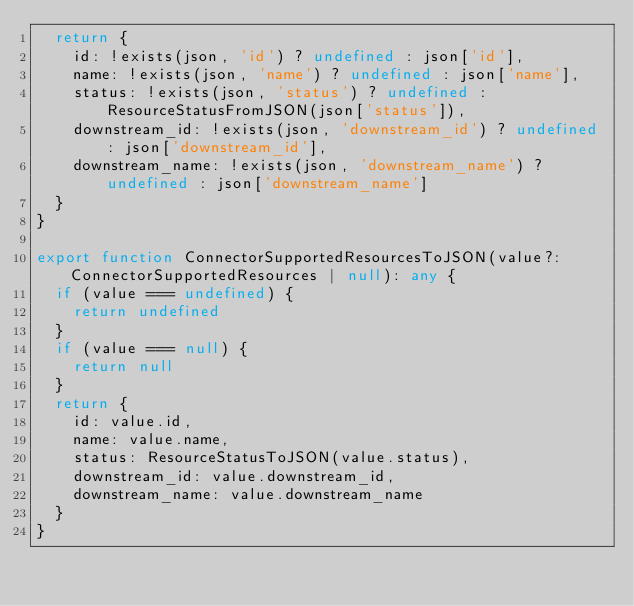Convert code to text. <code><loc_0><loc_0><loc_500><loc_500><_TypeScript_>  return {
    id: !exists(json, 'id') ? undefined : json['id'],
    name: !exists(json, 'name') ? undefined : json['name'],
    status: !exists(json, 'status') ? undefined : ResourceStatusFromJSON(json['status']),
    downstream_id: !exists(json, 'downstream_id') ? undefined : json['downstream_id'],
    downstream_name: !exists(json, 'downstream_name') ? undefined : json['downstream_name']
  }
}

export function ConnectorSupportedResourcesToJSON(value?: ConnectorSupportedResources | null): any {
  if (value === undefined) {
    return undefined
  }
  if (value === null) {
    return null
  }
  return {
    id: value.id,
    name: value.name,
    status: ResourceStatusToJSON(value.status),
    downstream_id: value.downstream_id,
    downstream_name: value.downstream_name
  }
}
</code> 